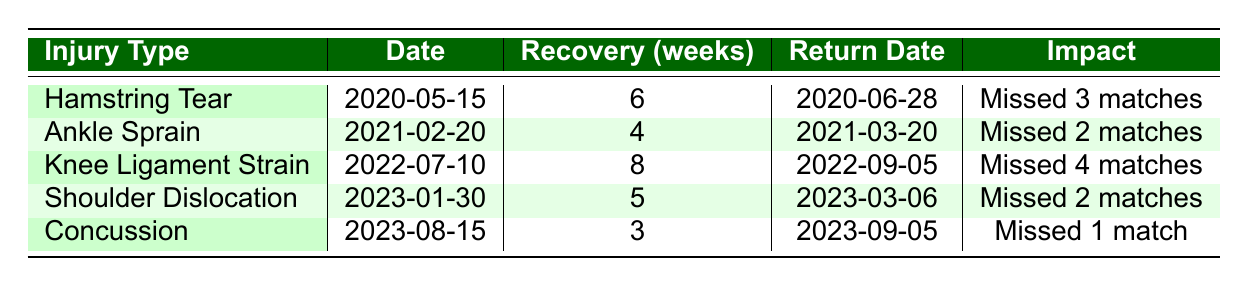What was Léo Laurent's first recorded injury? The first injury in the table is the Hamstring Tear, which occurred on 2020-05-15.
Answer: Hamstring Tear Which injury caused Léo Laurent to miss the most matches? The injury with the highest impact on performance is the Knee Ligament Strain, which caused Léo to miss 4 matches.
Answer: Knee Ligament Strain How long did Léo Laurent take to recover from the Ankle Sprain? The recovery time for the Ankle Sprain injury is recorded as 4 weeks.
Answer: 4 weeks Did Léo Laurent return to play after his Concussion injury on the same date as the return from his Shoulder Dislocation? The return date after the Concussion was 2023-09-05, while the return after the Shoulder Dislocation was 2023-03-06. Since these dates are different, the answer is no.
Answer: No What is the average recovery time for all injuries listed? To calculate the average recovery time, we first sum the recovery times: (6 + 4 + 8 + 5 + 3) = 26 weeks. Then we divide by the number of injuries (5), giving us an average of 26/5 = 5.2 weeks.
Answer: 5.2 weeks Which two injuries together resulted in missing a total of 5 matches? Examining the impact, the Hamstring Tear (3 matches) and the Ankle Sprain (2 matches) together total 5 matches. There are no other combinations that add to 5.
Answer: Hamstring Tear and Ankle Sprain How long after the Ankle Sprain did Léo Laurent return to play? Léo returned from the Ankle Sprain on 2021-03-20 after 4 weeks. The injury occurred on 2021-02-20. Therefore, he returned exactly 4 weeks later, which is consistent with the data.
Answer: 4 weeks Is it true that all injuries resulted in at least a 1 match suspension from play? All injuries listed in the table resulted in matches missed ranging from 1 to 4 matches, confirming that the statement is true.
Answer: Yes 